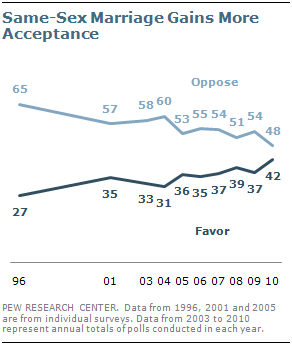Identify some key points in this picture. There were 2 instances where the value "37" appeared in the favor segment. The individual who opposes same-sex marriage but gains more acceptance is 48. 